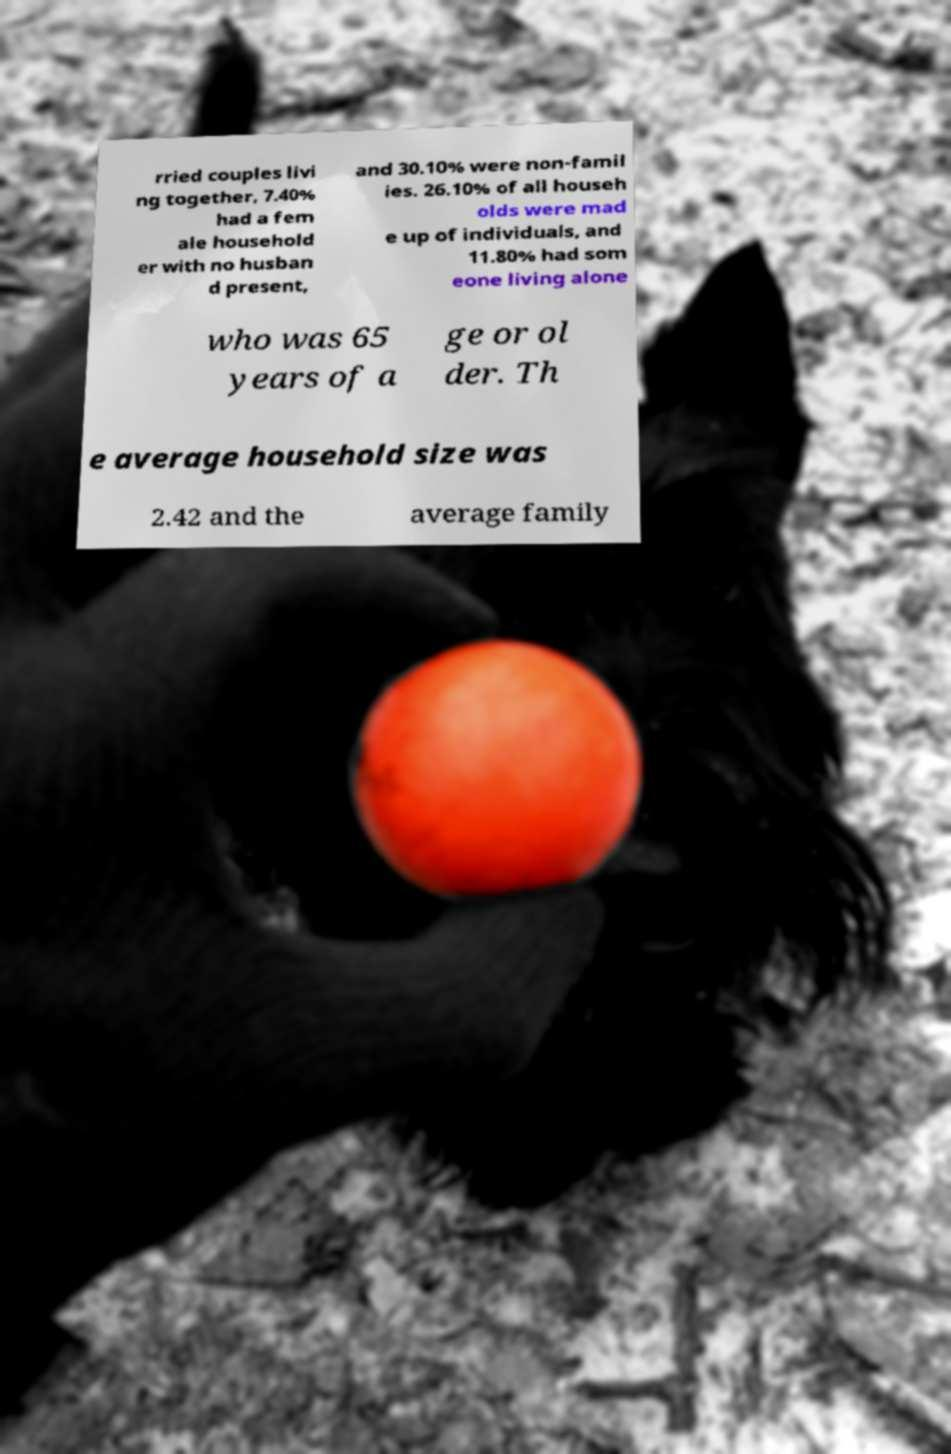Can you accurately transcribe the text from the provided image for me? rried couples livi ng together, 7.40% had a fem ale household er with no husban d present, and 30.10% were non-famil ies. 26.10% of all househ olds were mad e up of individuals, and 11.80% had som eone living alone who was 65 years of a ge or ol der. Th e average household size was 2.42 and the average family 